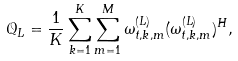Convert formula to latex. <formula><loc_0><loc_0><loc_500><loc_500>\mathcal { Q } _ { L } = \frac { 1 } { K } \sum _ { k = 1 } ^ { K } \sum _ { m = 1 } ^ { M } \omega _ { t , k , m } ^ { ( L ) } ( \omega _ { t , k , m } ^ { ( L ) } ) ^ { H } ,</formula> 